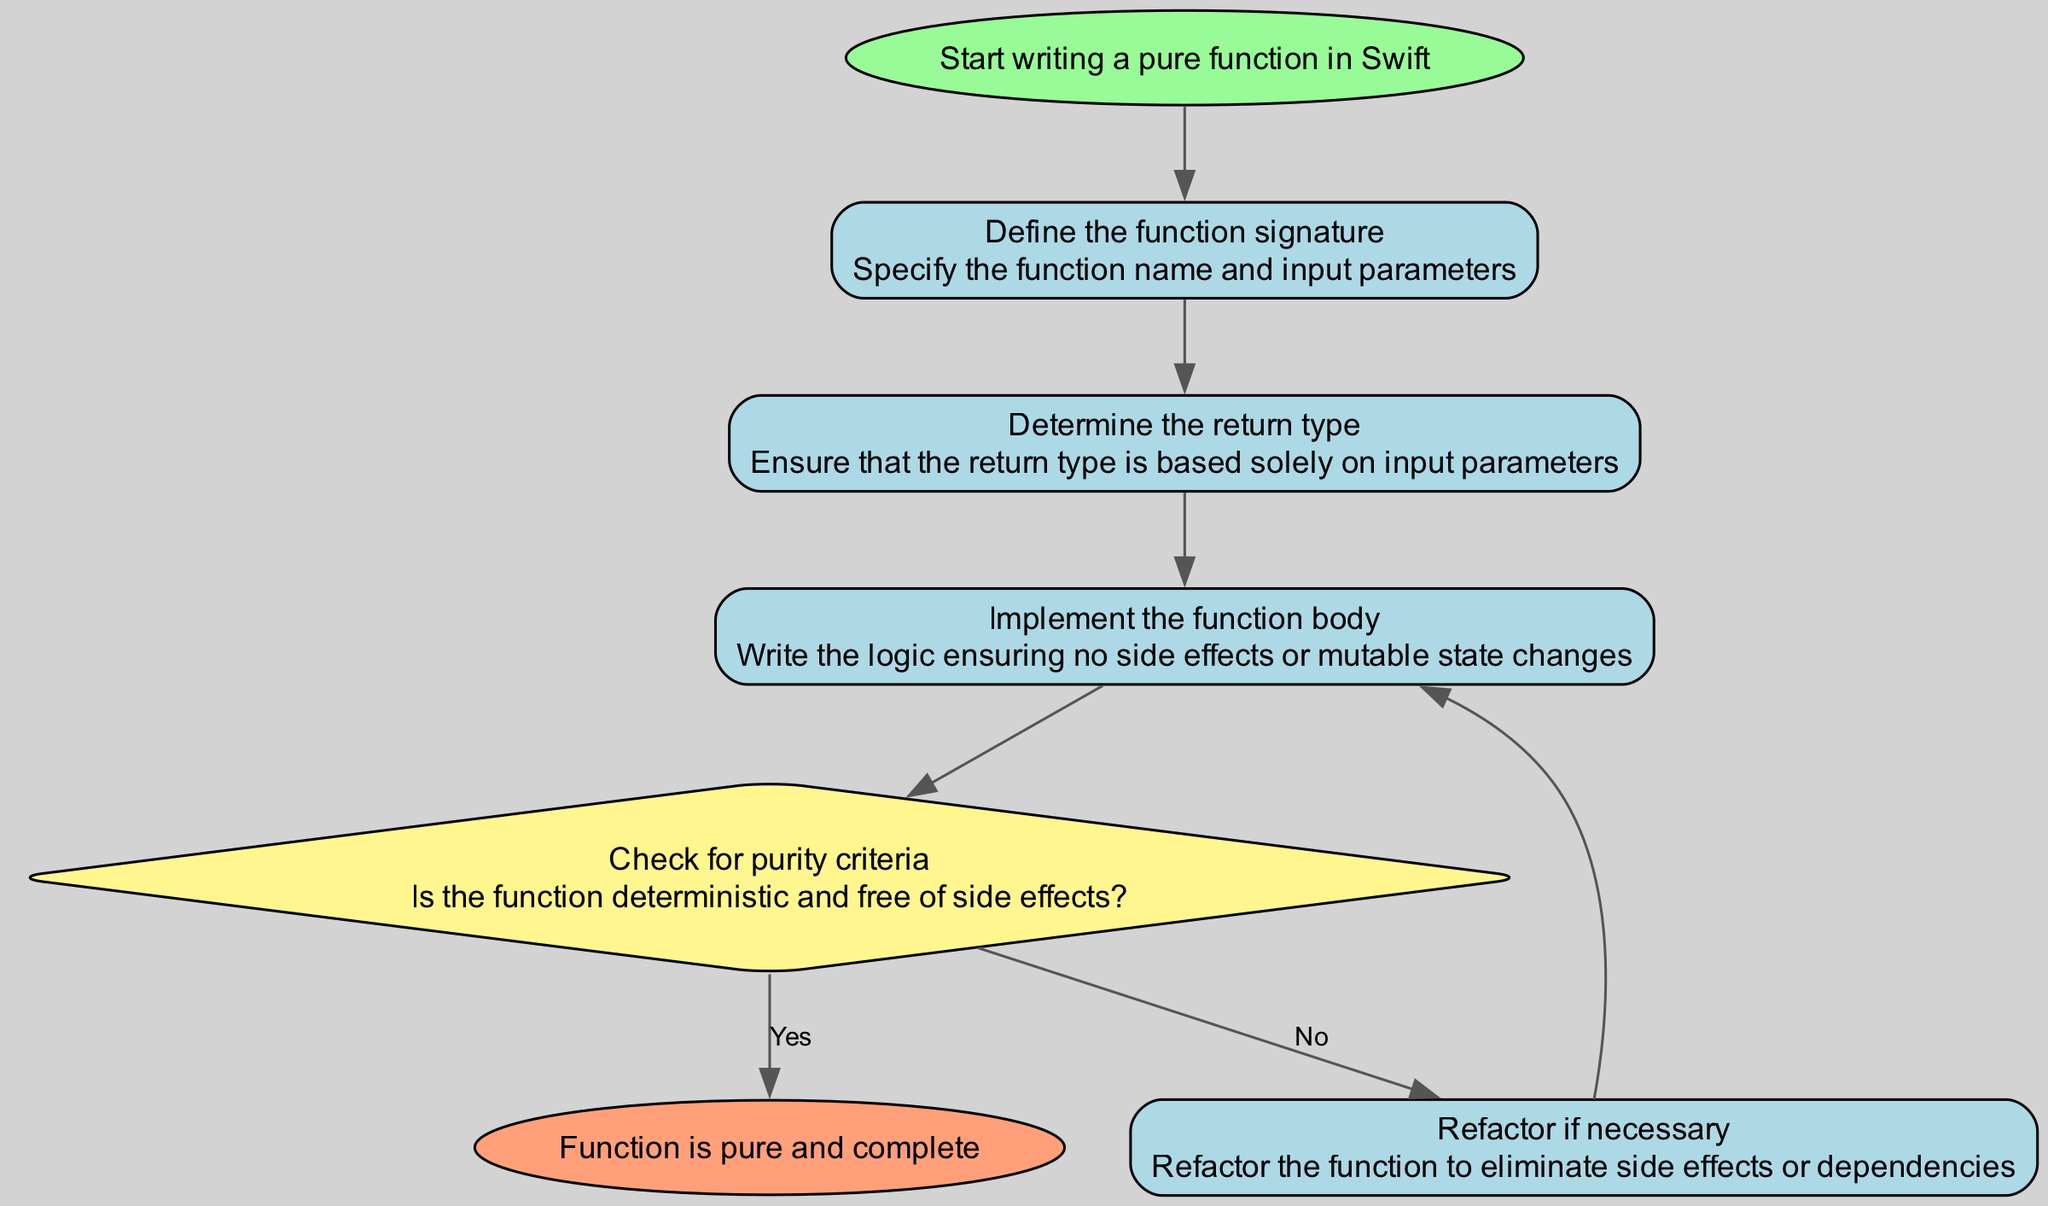What is the starting point of the diagram? The starting point of the diagram is labeled as "Start writing a pure function in Swift." This is identified as the first element in the flow chart, which indicates the beginning of the process.
Answer: Start writing a pure function in Swift How many process nodes are present in the diagram? The diagram has four process nodes: "Define the function signature," "Determine the return type," "Implement the function body," and "Refactor if necessary." By counting these nodes, we find a total of four process steps in the instruction.
Answer: 4 What follows after implementing the function body? After "Implement the function body," the next step is "Check for purity criteria." This connection can be tracked through the flow from the implementation node to the purity check node.
Answer: Check for purity criteria What is the outcome if the function is found to be pure? If the function is determined to be pure, the next step is labeled "Function is pure and complete." This outcome follows directly from the decision node when the purity condition is met.
Answer: Function is pure and complete What action is taken if the function is not pure? If the function is not pure, the flow chart indicates that the action is to "Refactor if necessary." This node leads back to "Implement the function body" to address issues of purity.
Answer: Refactor if necessary How many edges connect the nodes in total? The diagram contains six edges that connect the nodes: one from each process and decision node, including the conditional edges based on the purity check outcome. By counting each connection, we find a total of six edges in the flow.
Answer: 6 